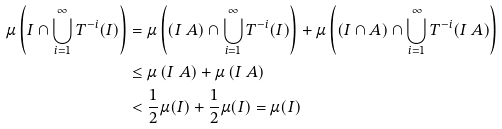<formula> <loc_0><loc_0><loc_500><loc_500>\mu \left ( I \cap \bigcup _ { i = 1 } ^ { \infty } T ^ { - i } ( I ) \right ) & = \mu \left ( ( I \ A ) \cap \bigcup _ { i = 1 } ^ { \infty } T ^ { - i } ( I ) \right ) + \mu \left ( ( I \cap A ) \cap \bigcup _ { i = 1 } ^ { \infty } T ^ { - i } ( I \ A ) \right ) \\ & \leq \mu \left ( I \ A \right ) + \mu \left ( I \ A \right ) \\ & < \frac { 1 } { 2 } \mu ( I ) + \frac { 1 } { 2 } \mu ( I ) = \mu ( I )</formula> 